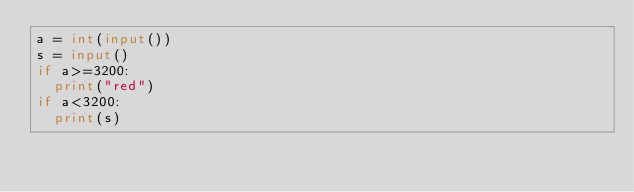<code> <loc_0><loc_0><loc_500><loc_500><_Python_>a = int(input())
s = input()
if a>=3200:
  print("red")
if a<3200:
  print(s)</code> 